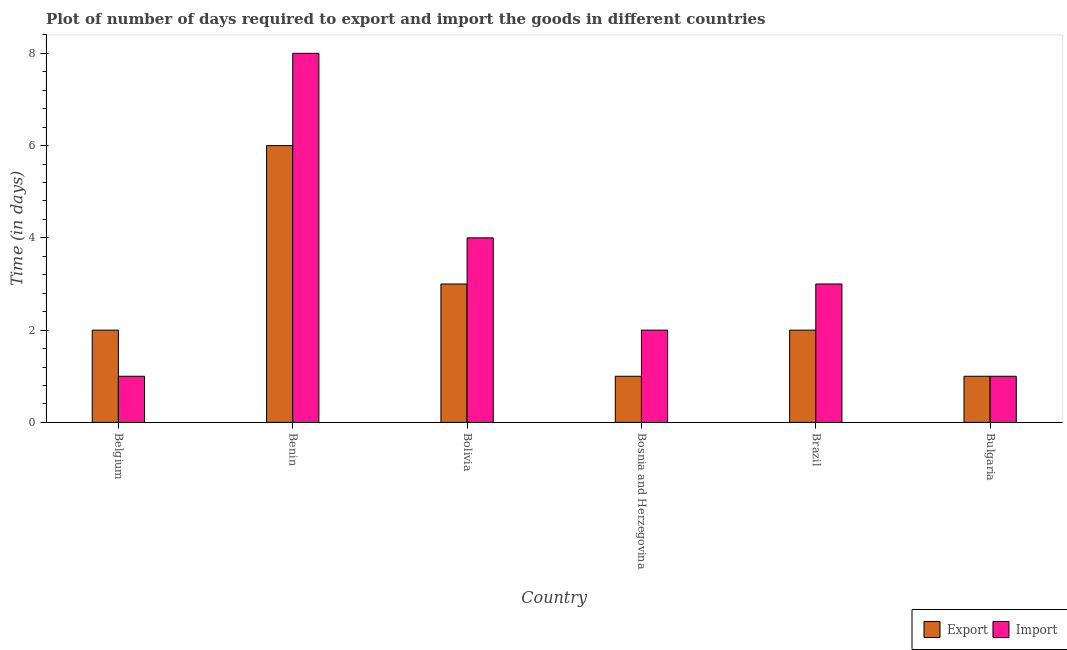How many different coloured bars are there?
Offer a terse response. 2. Are the number of bars per tick equal to the number of legend labels?
Keep it short and to the point. Yes. Are the number of bars on each tick of the X-axis equal?
Give a very brief answer. Yes. In how many cases, is the number of bars for a given country not equal to the number of legend labels?
Your response must be concise. 0. What is the time required to export in Bulgaria?
Your response must be concise. 1. Across all countries, what is the maximum time required to import?
Offer a very short reply. 8. In which country was the time required to import maximum?
Ensure brevity in your answer.  Benin. In which country was the time required to export minimum?
Your response must be concise. Bosnia and Herzegovina. What is the average time required to export per country?
Keep it short and to the point. 2.5. What is the difference between the time required to export and time required to import in Brazil?
Offer a very short reply. -1. Is the difference between the time required to import in Brazil and Bulgaria greater than the difference between the time required to export in Brazil and Bulgaria?
Your answer should be very brief. Yes. What is the difference between the highest and the second highest time required to export?
Offer a terse response. 3. What does the 2nd bar from the left in Bulgaria represents?
Provide a short and direct response. Import. What does the 1st bar from the right in Brazil represents?
Offer a very short reply. Import. Does the graph contain any zero values?
Your answer should be compact. No. Does the graph contain grids?
Your answer should be compact. No. Where does the legend appear in the graph?
Provide a succinct answer. Bottom right. How many legend labels are there?
Ensure brevity in your answer.  2. How are the legend labels stacked?
Ensure brevity in your answer.  Horizontal. What is the title of the graph?
Your answer should be very brief. Plot of number of days required to export and import the goods in different countries. Does "GDP at market prices" appear as one of the legend labels in the graph?
Give a very brief answer. No. What is the label or title of the X-axis?
Offer a terse response. Country. What is the label or title of the Y-axis?
Provide a short and direct response. Time (in days). What is the Time (in days) in Export in Belgium?
Offer a terse response. 2. What is the Time (in days) of Import in Belgium?
Offer a very short reply. 1. What is the Time (in days) of Import in Benin?
Provide a short and direct response. 8. What is the Time (in days) in Import in Bolivia?
Offer a terse response. 4. What is the Time (in days) of Import in Bosnia and Herzegovina?
Make the answer very short. 2. What is the Time (in days) of Import in Bulgaria?
Ensure brevity in your answer.  1. Across all countries, what is the maximum Time (in days) in Import?
Ensure brevity in your answer.  8. Across all countries, what is the minimum Time (in days) of Export?
Keep it short and to the point. 1. Across all countries, what is the minimum Time (in days) of Import?
Make the answer very short. 1. What is the difference between the Time (in days) in Import in Belgium and that in Benin?
Ensure brevity in your answer.  -7. What is the difference between the Time (in days) of Import in Belgium and that in Bolivia?
Provide a short and direct response. -3. What is the difference between the Time (in days) of Export in Belgium and that in Bosnia and Herzegovina?
Provide a succinct answer. 1. What is the difference between the Time (in days) in Import in Belgium and that in Bosnia and Herzegovina?
Provide a succinct answer. -1. What is the difference between the Time (in days) in Export in Belgium and that in Brazil?
Give a very brief answer. 0. What is the difference between the Time (in days) in Export in Benin and that in Bolivia?
Give a very brief answer. 3. What is the difference between the Time (in days) of Import in Benin and that in Bolivia?
Your answer should be very brief. 4. What is the difference between the Time (in days) in Export in Benin and that in Bosnia and Herzegovina?
Give a very brief answer. 5. What is the difference between the Time (in days) of Import in Benin and that in Bosnia and Herzegovina?
Your answer should be very brief. 6. What is the difference between the Time (in days) of Export in Benin and that in Bulgaria?
Provide a short and direct response. 5. What is the difference between the Time (in days) of Import in Benin and that in Bulgaria?
Give a very brief answer. 7. What is the difference between the Time (in days) of Export in Bolivia and that in Bosnia and Herzegovina?
Your answer should be compact. 2. What is the difference between the Time (in days) of Export in Bolivia and that in Bulgaria?
Make the answer very short. 2. What is the difference between the Time (in days) of Export in Bosnia and Herzegovina and that in Brazil?
Ensure brevity in your answer.  -1. What is the difference between the Time (in days) in Import in Bosnia and Herzegovina and that in Brazil?
Ensure brevity in your answer.  -1. What is the difference between the Time (in days) of Import in Bosnia and Herzegovina and that in Bulgaria?
Offer a terse response. 1. What is the difference between the Time (in days) of Export in Belgium and the Time (in days) of Import in Brazil?
Your response must be concise. -1. What is the difference between the Time (in days) in Export in Belgium and the Time (in days) in Import in Bulgaria?
Your response must be concise. 1. What is the difference between the Time (in days) of Export in Benin and the Time (in days) of Import in Bolivia?
Provide a succinct answer. 2. What is the difference between the Time (in days) in Export in Bolivia and the Time (in days) in Import in Bulgaria?
Your answer should be very brief. 2. What is the difference between the Time (in days) of Export in Bosnia and Herzegovina and the Time (in days) of Import in Bulgaria?
Your response must be concise. 0. What is the average Time (in days) in Export per country?
Your answer should be compact. 2.5. What is the average Time (in days) of Import per country?
Provide a succinct answer. 3.17. What is the difference between the Time (in days) of Export and Time (in days) of Import in Belgium?
Offer a very short reply. 1. What is the difference between the Time (in days) in Export and Time (in days) in Import in Bosnia and Herzegovina?
Your response must be concise. -1. What is the ratio of the Time (in days) in Export in Belgium to that in Benin?
Your response must be concise. 0.33. What is the ratio of the Time (in days) of Import in Belgium to that in Benin?
Your response must be concise. 0.12. What is the ratio of the Time (in days) in Export in Belgium to that in Bosnia and Herzegovina?
Your answer should be compact. 2. What is the ratio of the Time (in days) in Import in Belgium to that in Bosnia and Herzegovina?
Offer a very short reply. 0.5. What is the ratio of the Time (in days) in Import in Belgium to that in Brazil?
Give a very brief answer. 0.33. What is the ratio of the Time (in days) of Export in Belgium to that in Bulgaria?
Provide a succinct answer. 2. What is the ratio of the Time (in days) in Import in Belgium to that in Bulgaria?
Your answer should be very brief. 1. What is the ratio of the Time (in days) of Import in Benin to that in Bolivia?
Make the answer very short. 2. What is the ratio of the Time (in days) in Export in Benin to that in Bosnia and Herzegovina?
Give a very brief answer. 6. What is the ratio of the Time (in days) in Import in Benin to that in Bosnia and Herzegovina?
Offer a very short reply. 4. What is the ratio of the Time (in days) of Export in Benin to that in Brazil?
Your answer should be compact. 3. What is the ratio of the Time (in days) in Import in Benin to that in Brazil?
Your answer should be very brief. 2.67. What is the ratio of the Time (in days) in Export in Benin to that in Bulgaria?
Provide a succinct answer. 6. What is the ratio of the Time (in days) of Import in Benin to that in Bulgaria?
Provide a short and direct response. 8. What is the ratio of the Time (in days) of Import in Bolivia to that in Bosnia and Herzegovina?
Provide a succinct answer. 2. What is the ratio of the Time (in days) of Export in Bolivia to that in Brazil?
Give a very brief answer. 1.5. What is the ratio of the Time (in days) in Import in Bolivia to that in Bulgaria?
Offer a very short reply. 4. What is the difference between the highest and the second highest Time (in days) in Export?
Provide a short and direct response. 3. What is the difference between the highest and the second highest Time (in days) in Import?
Keep it short and to the point. 4. 